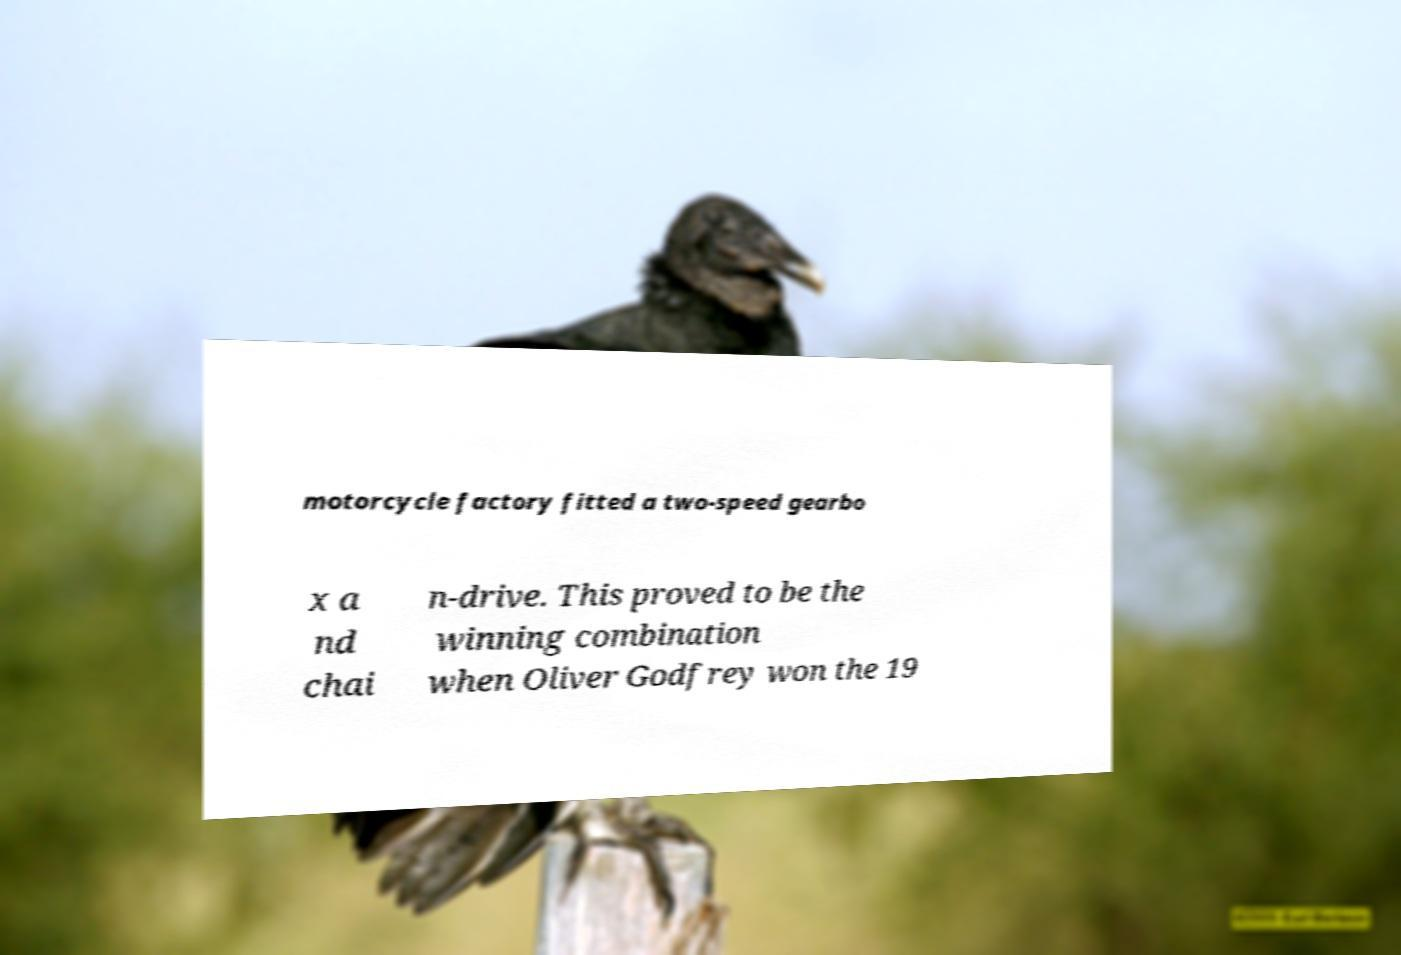I need the written content from this picture converted into text. Can you do that? motorcycle factory fitted a two-speed gearbo x a nd chai n-drive. This proved to be the winning combination when Oliver Godfrey won the 19 